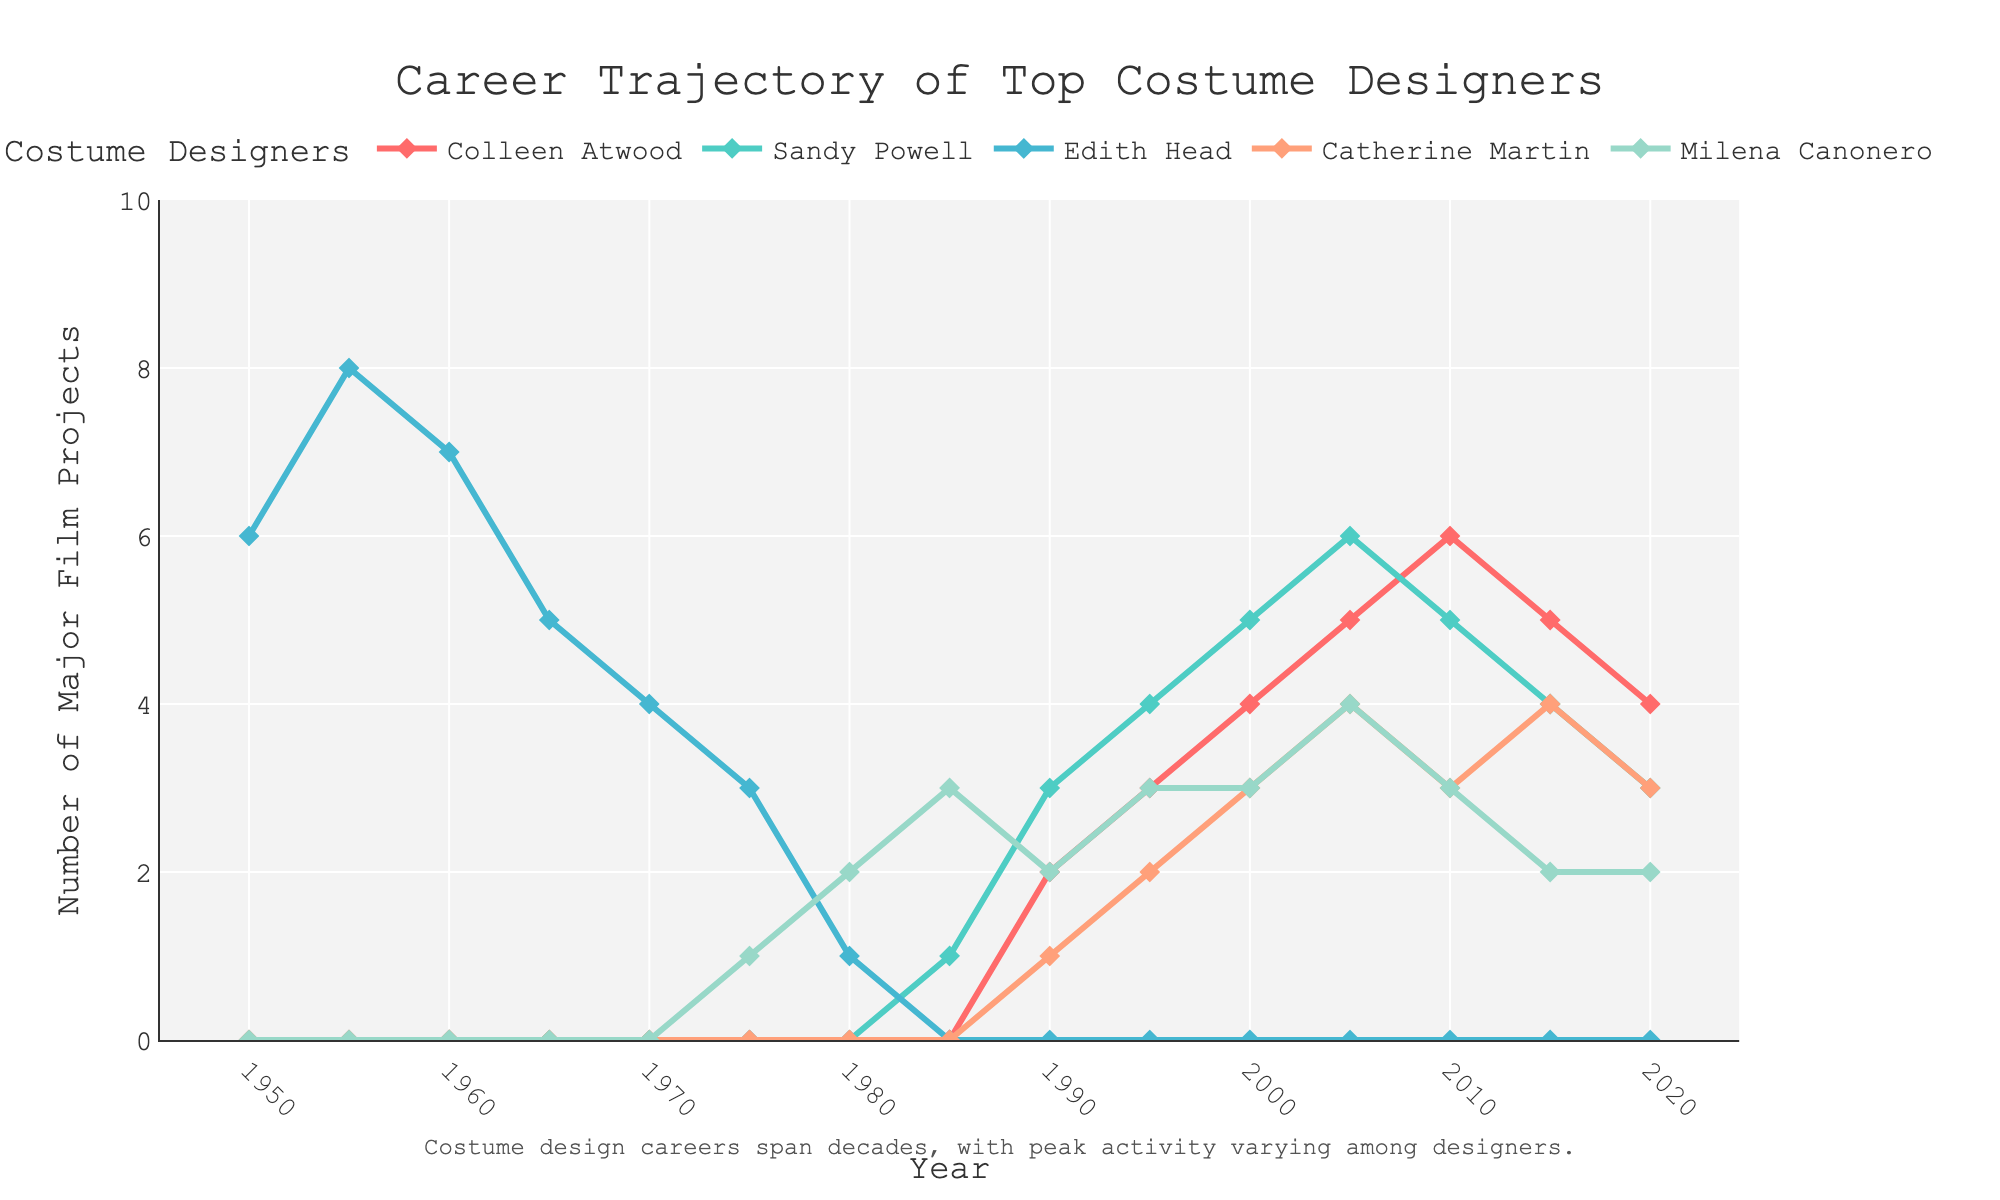What's the highest number of major film projects Edith Head worked on in a year? To find the highest number of major film projects Edith Head worked on in a year, look at the peaks of her line on the chart. Notice that her line only appears in the early years and peaks at 8 in 1955.
Answer: 8 What is the average number of major film projects per year for Catherine Martin between 2000 and 2020? To calculate the average, sum the number of major film projects Catherine Martin worked on in the years mentioned (3, 4, 3, 3, 4, 3) and divide by the number of years (6). Thus, (3 + 4 + 3 + 4 + 3) / 6 = 3.33.
Answer: 3.33 Did Colleen Atwood or Sandy Powell start their career in major film projects earlier? To identify who started earlier, look at when their lines emerge from zero on the x-axis. Sandy Powell's line emerges in 1985, whereas Colleen Atwood’s line starts in 1990. Thus, Sandy Powell started earlier.
Answer: Sandy Powell Who experienced the most fluctuating career trajectory and why? To determine the most fluctuating career trajectory, observe the variability in the lines. Colleen Atwood's line fluctuates significantly, especially between 2010 and 2020, where her project count descends from 6 to 4, showing an obvious pattern of rise and fall.
Answer: Colleen Atwood By how many projects does Milena Canonero's peak year differ from Sandy Powell's peak year? Identify the peak project years for both designers. Milena Canonero's peak is 4 projects in 2005, and Sandy Powell's peak is 6 projects in 2005. The difference is 6 - 4 = 2 projects.
Answer: 2 Did any designer have a continuous increase in the number of major film projects for three consecutive periods? Check each designer's trajectory for any consecutive increases over three periods. Colleen Atwood's career shows an increase from 1990 (2) to 2005 (5), marking a continuous rise.
Answer: Colleen Atwood Which designer had consistently zero major film projects after 1975? By observing the lines on the graph, Edith Head has a line that drops to zero after 1975 and remains there, indicating no major projects post-1975.
Answer: Edith Head What is the difference between the highest number of major film projects by Sandy Powell and Catherine Martin? Identify the peak project numbers for each designer. Sandy Powell’s peak is 6, and Catherine Martin’s is 4. Thus, the difference is 6 - 4 = 2.
Answer: 2 What is the trend for major film projects for Milena Canonero from 1980 to 2020? Examine how Milena Canonero's line changes. She starts at 2 projects in 1980, peaks at 4 in 2005, and then trends down to 2 by 2020. The trend is an initial increase followed by a decrease.
Answer: Increase then decrease 